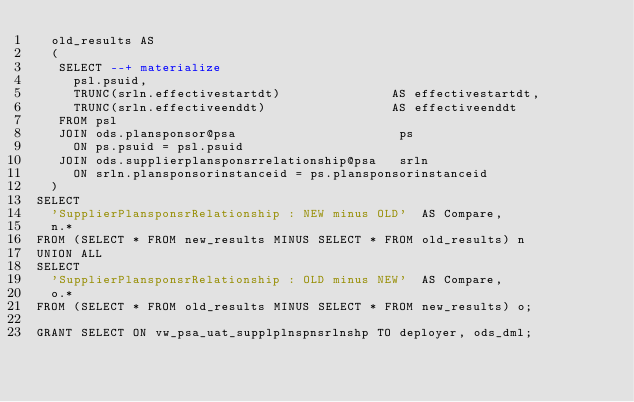<code> <loc_0><loc_0><loc_500><loc_500><_SQL_>  old_results AS
  (
   SELECT --+ materialize
     psl.psuid,
     TRUNC(srln.effectivestartdt)               AS effectivestartdt,
     TRUNC(srln.effectiveenddt)                 AS effectiveenddt
   FROM psl                             
   JOIN ods.plansponsor@psa                      ps 
     ON ps.psuid = psl.psuid                            
   JOIN ods.supplierplansponsrrelationship@psa   srln
     ON srln.plansponsorinstanceid = ps.plansponsorinstanceid
  )
SELECT
  'SupplierPlansponsrRelationship : NEW minus OLD'  AS Compare,
  n.* 
FROM (SELECT * FROM new_results MINUS SELECT * FROM old_results) n
UNION ALL
SELECT
  'SupplierPlansponsrRelationship : OLD minus NEW'  AS Compare,
  o.* 
FROM (SELECT * FROM old_results MINUS SELECT * FROM new_results) o;

GRANT SELECT ON vw_psa_uat_supplplnspnsrlnshp TO deployer, ods_dml;</code> 